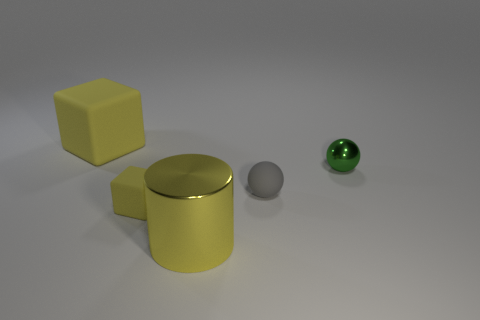What number of other objects are the same color as the big metallic thing?
Ensure brevity in your answer.  2. What number of cubes are tiny objects or large objects?
Offer a terse response. 2. What shape is the small yellow thing?
Offer a terse response. Cube. There is a yellow metal object; are there any tiny gray objects on the right side of it?
Your answer should be compact. Yes. Is the material of the yellow cylinder the same as the tiny thing that is on the left side of the big yellow metal object?
Provide a short and direct response. No. There is a tiny object that is right of the small rubber ball; is its shape the same as the small gray rubber object?
Provide a short and direct response. Yes. How many brown balls have the same material as the small block?
Your answer should be compact. 0. What number of things are either matte things to the right of the large matte cube or big metallic things?
Give a very brief answer. 3. What size is the green ball?
Provide a succinct answer. Small. The cube in front of the rubber cube that is behind the tiny green thing is made of what material?
Make the answer very short. Rubber. 